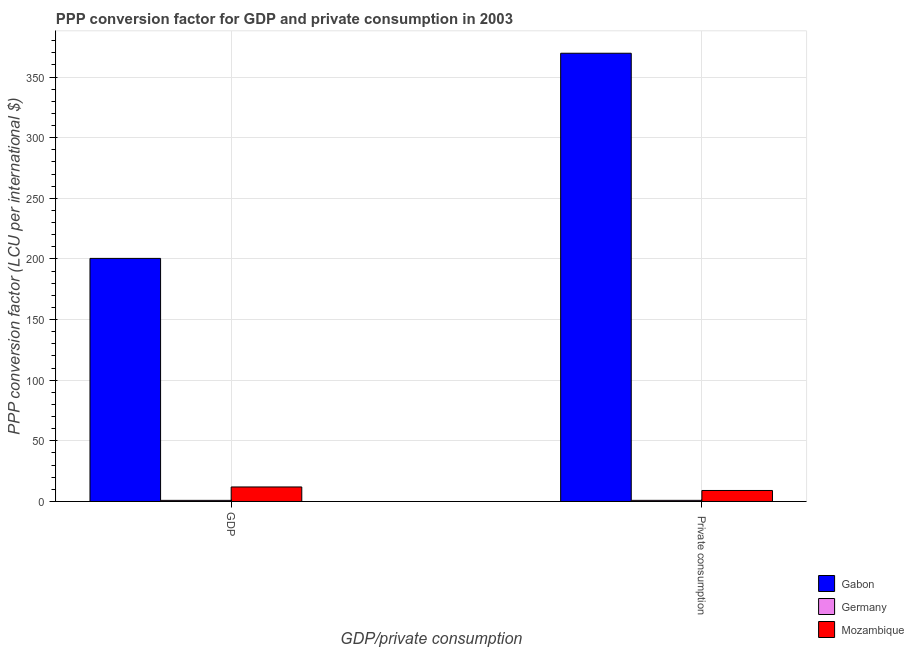How many groups of bars are there?
Ensure brevity in your answer.  2. Are the number of bars per tick equal to the number of legend labels?
Offer a terse response. Yes. Are the number of bars on each tick of the X-axis equal?
Your answer should be very brief. Yes. How many bars are there on the 2nd tick from the right?
Provide a succinct answer. 3. What is the label of the 1st group of bars from the left?
Ensure brevity in your answer.  GDP. What is the ppp conversion factor for private consumption in Mozambique?
Provide a succinct answer. 9.06. Across all countries, what is the maximum ppp conversion factor for private consumption?
Keep it short and to the point. 369.66. Across all countries, what is the minimum ppp conversion factor for gdp?
Ensure brevity in your answer.  0.92. In which country was the ppp conversion factor for private consumption maximum?
Make the answer very short. Gabon. In which country was the ppp conversion factor for gdp minimum?
Give a very brief answer. Germany. What is the total ppp conversion factor for private consumption in the graph?
Offer a terse response. 379.64. What is the difference between the ppp conversion factor for gdp in Mozambique and that in Gabon?
Give a very brief answer. -188.5. What is the difference between the ppp conversion factor for gdp in Mozambique and the ppp conversion factor for private consumption in Germany?
Give a very brief answer. 11.04. What is the average ppp conversion factor for gdp per country?
Provide a succinct answer. 71.12. What is the difference between the ppp conversion factor for gdp and ppp conversion factor for private consumption in Germany?
Your answer should be very brief. -0.01. What is the ratio of the ppp conversion factor for gdp in Mozambique to that in Germany?
Your answer should be very brief. 13.06. What does the 1st bar from the left in GDP represents?
Your answer should be very brief. Gabon. What does the 1st bar from the right in  Private consumption represents?
Ensure brevity in your answer.  Mozambique. How many countries are there in the graph?
Keep it short and to the point. 3. Are the values on the major ticks of Y-axis written in scientific E-notation?
Your answer should be compact. No. Does the graph contain any zero values?
Ensure brevity in your answer.  No. Does the graph contain grids?
Keep it short and to the point. Yes. Where does the legend appear in the graph?
Provide a short and direct response. Bottom right. What is the title of the graph?
Offer a terse response. PPP conversion factor for GDP and private consumption in 2003. What is the label or title of the X-axis?
Your response must be concise. GDP/private consumption. What is the label or title of the Y-axis?
Make the answer very short. PPP conversion factor (LCU per international $). What is the PPP conversion factor (LCU per international $) of Gabon in GDP?
Ensure brevity in your answer.  200.46. What is the PPP conversion factor (LCU per international $) of Germany in GDP?
Ensure brevity in your answer.  0.92. What is the PPP conversion factor (LCU per international $) in Mozambique in GDP?
Provide a short and direct response. 11.96. What is the PPP conversion factor (LCU per international $) in Gabon in  Private consumption?
Your response must be concise. 369.66. What is the PPP conversion factor (LCU per international $) in Germany in  Private consumption?
Give a very brief answer. 0.92. What is the PPP conversion factor (LCU per international $) of Mozambique in  Private consumption?
Give a very brief answer. 9.06. Across all GDP/private consumption, what is the maximum PPP conversion factor (LCU per international $) in Gabon?
Provide a succinct answer. 369.66. Across all GDP/private consumption, what is the maximum PPP conversion factor (LCU per international $) in Germany?
Your answer should be compact. 0.92. Across all GDP/private consumption, what is the maximum PPP conversion factor (LCU per international $) of Mozambique?
Provide a succinct answer. 11.96. Across all GDP/private consumption, what is the minimum PPP conversion factor (LCU per international $) in Gabon?
Your answer should be compact. 200.46. Across all GDP/private consumption, what is the minimum PPP conversion factor (LCU per international $) in Germany?
Ensure brevity in your answer.  0.92. Across all GDP/private consumption, what is the minimum PPP conversion factor (LCU per international $) in Mozambique?
Ensure brevity in your answer.  9.06. What is the total PPP conversion factor (LCU per international $) in Gabon in the graph?
Provide a succinct answer. 570.12. What is the total PPP conversion factor (LCU per international $) in Germany in the graph?
Your answer should be compact. 1.84. What is the total PPP conversion factor (LCU per international $) in Mozambique in the graph?
Offer a very short reply. 21.03. What is the difference between the PPP conversion factor (LCU per international $) in Gabon in GDP and that in  Private consumption?
Provide a short and direct response. -169.19. What is the difference between the PPP conversion factor (LCU per international $) in Germany in GDP and that in  Private consumption?
Offer a very short reply. -0.01. What is the difference between the PPP conversion factor (LCU per international $) of Mozambique in GDP and that in  Private consumption?
Give a very brief answer. 2.9. What is the difference between the PPP conversion factor (LCU per international $) of Gabon in GDP and the PPP conversion factor (LCU per international $) of Germany in  Private consumption?
Ensure brevity in your answer.  199.54. What is the difference between the PPP conversion factor (LCU per international $) of Gabon in GDP and the PPP conversion factor (LCU per international $) of Mozambique in  Private consumption?
Your answer should be compact. 191.4. What is the difference between the PPP conversion factor (LCU per international $) in Germany in GDP and the PPP conversion factor (LCU per international $) in Mozambique in  Private consumption?
Your answer should be compact. -8.15. What is the average PPP conversion factor (LCU per international $) in Gabon per GDP/private consumption?
Keep it short and to the point. 285.06. What is the average PPP conversion factor (LCU per international $) of Germany per GDP/private consumption?
Give a very brief answer. 0.92. What is the average PPP conversion factor (LCU per international $) in Mozambique per GDP/private consumption?
Provide a short and direct response. 10.51. What is the difference between the PPP conversion factor (LCU per international $) in Gabon and PPP conversion factor (LCU per international $) in Germany in GDP?
Ensure brevity in your answer.  199.55. What is the difference between the PPP conversion factor (LCU per international $) in Gabon and PPP conversion factor (LCU per international $) in Mozambique in GDP?
Keep it short and to the point. 188.5. What is the difference between the PPP conversion factor (LCU per international $) of Germany and PPP conversion factor (LCU per international $) of Mozambique in GDP?
Your response must be concise. -11.05. What is the difference between the PPP conversion factor (LCU per international $) of Gabon and PPP conversion factor (LCU per international $) of Germany in  Private consumption?
Offer a terse response. 368.73. What is the difference between the PPP conversion factor (LCU per international $) of Gabon and PPP conversion factor (LCU per international $) of Mozambique in  Private consumption?
Your answer should be compact. 360.59. What is the difference between the PPP conversion factor (LCU per international $) of Germany and PPP conversion factor (LCU per international $) of Mozambique in  Private consumption?
Give a very brief answer. -8.14. What is the ratio of the PPP conversion factor (LCU per international $) in Gabon in GDP to that in  Private consumption?
Provide a short and direct response. 0.54. What is the ratio of the PPP conversion factor (LCU per international $) of Germany in GDP to that in  Private consumption?
Offer a terse response. 0.99. What is the ratio of the PPP conversion factor (LCU per international $) in Mozambique in GDP to that in  Private consumption?
Provide a succinct answer. 1.32. What is the difference between the highest and the second highest PPP conversion factor (LCU per international $) of Gabon?
Offer a very short reply. 169.19. What is the difference between the highest and the second highest PPP conversion factor (LCU per international $) of Germany?
Your answer should be very brief. 0.01. What is the difference between the highest and the second highest PPP conversion factor (LCU per international $) of Mozambique?
Offer a very short reply. 2.9. What is the difference between the highest and the lowest PPP conversion factor (LCU per international $) in Gabon?
Give a very brief answer. 169.19. What is the difference between the highest and the lowest PPP conversion factor (LCU per international $) in Germany?
Give a very brief answer. 0.01. What is the difference between the highest and the lowest PPP conversion factor (LCU per international $) in Mozambique?
Give a very brief answer. 2.9. 